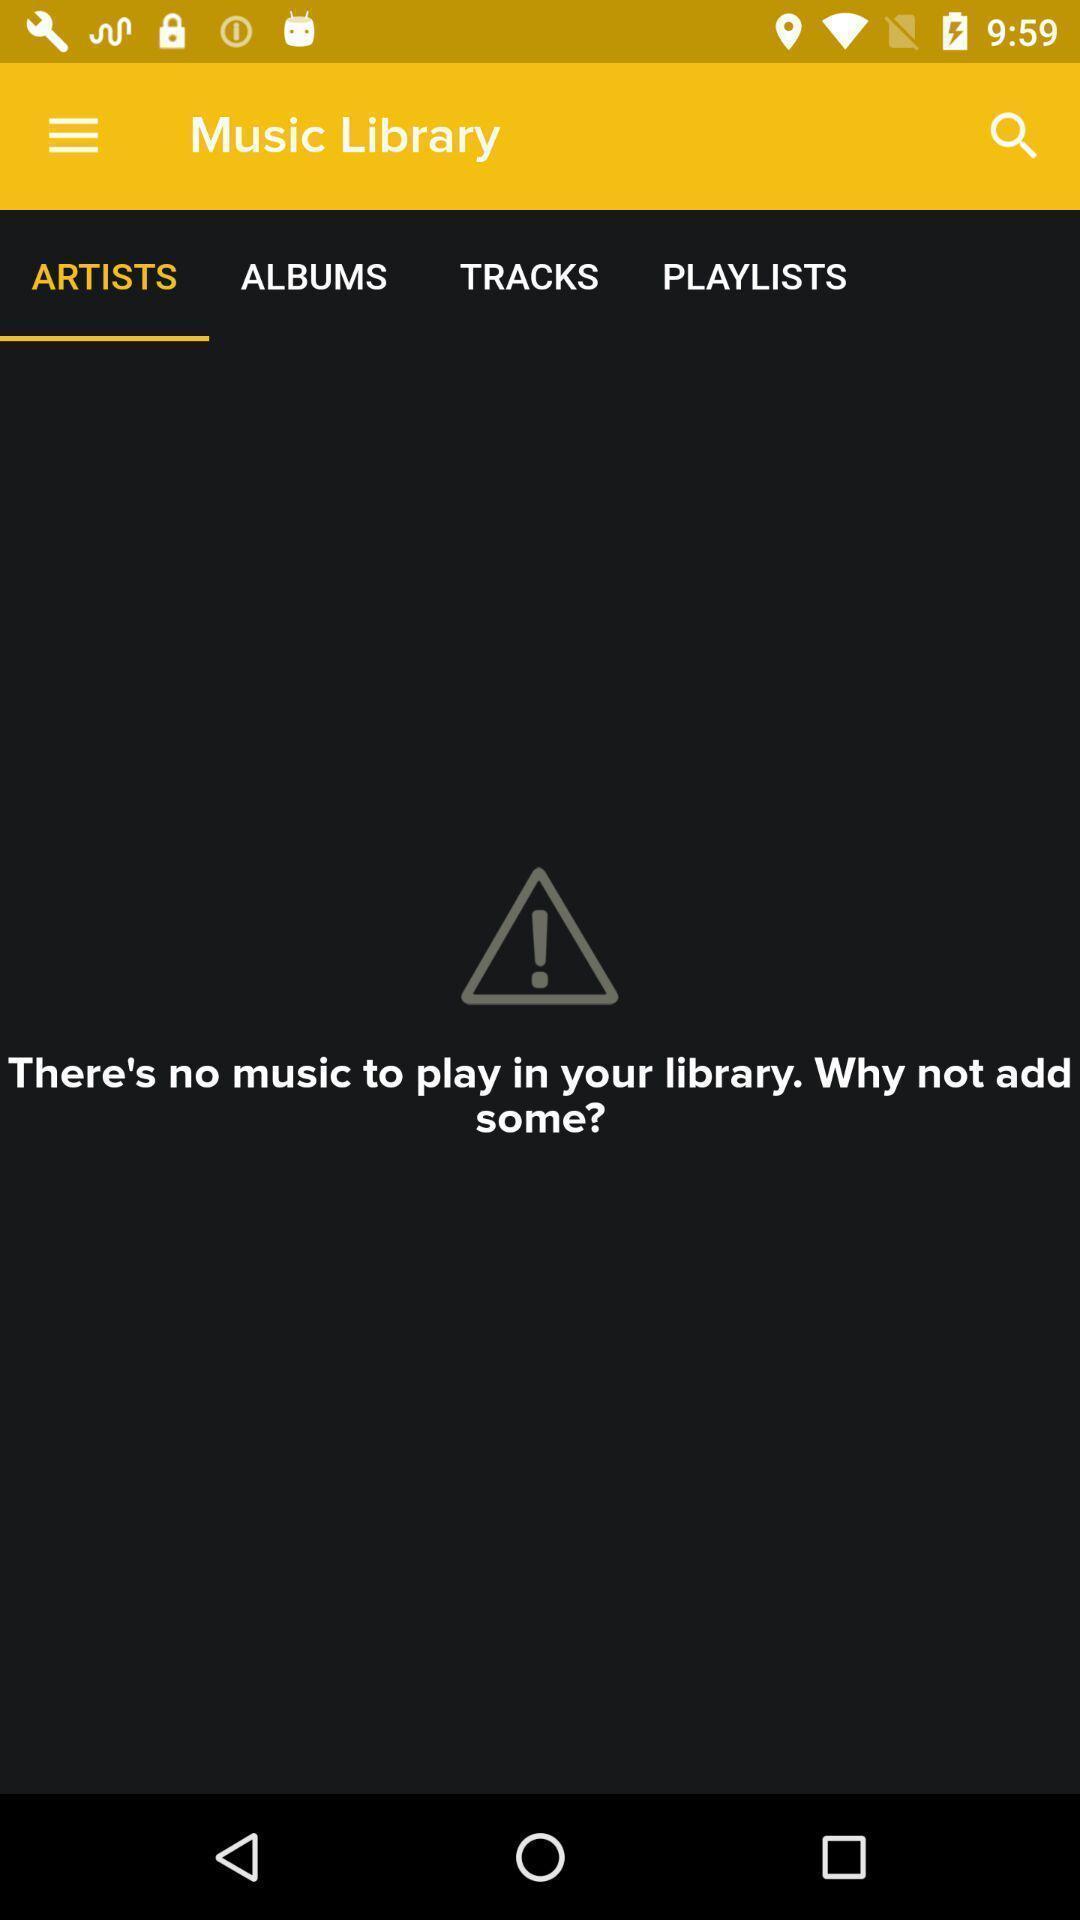Provide a textual representation of this image. Screen shows details in a music application. 